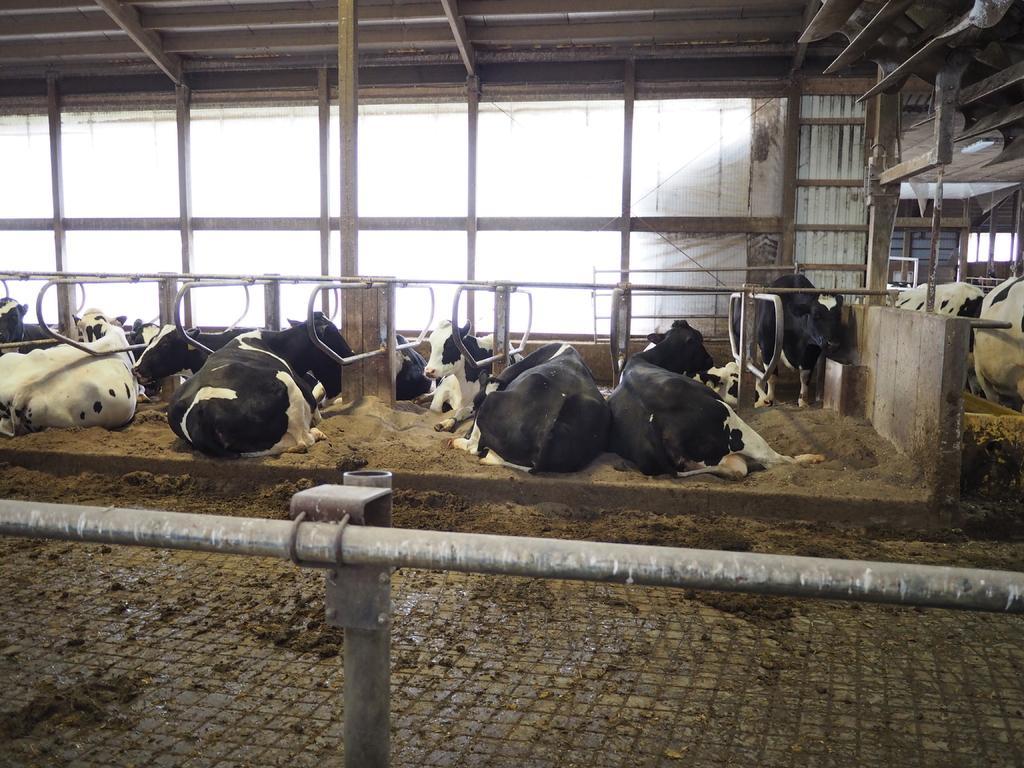Please provide a concise description of this image. In this image we can see cows. Also there are pillars and pipes. In the back we can see glass walls. 